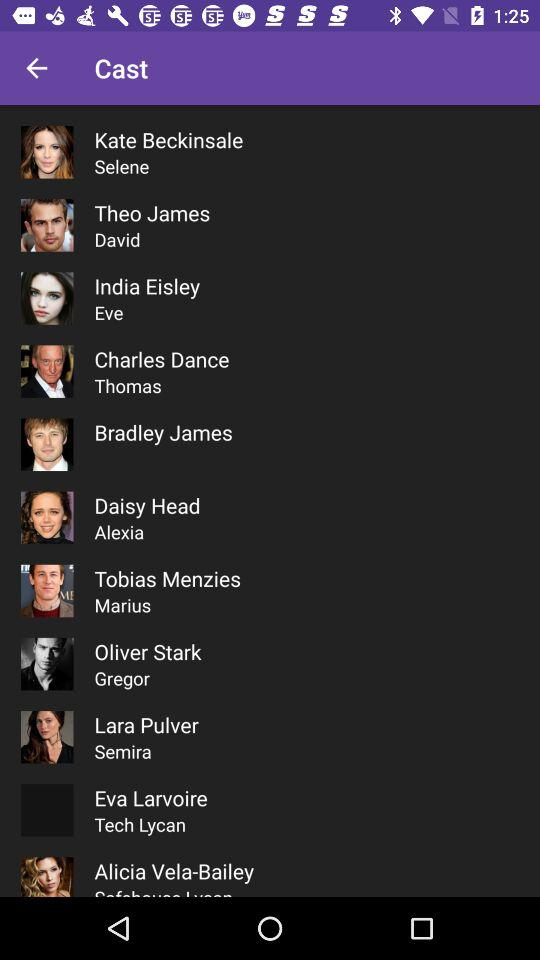What is the name of the artists available in the list? The names of the artists available in the list are Kate Beckinsale, Theo James, India Eisley, Charles Dance, Bradley James, Daisy Head, Tobias Menzies, Oliver Stark, Lara Pulver, Eva Larvoire, Alicia Vela-Bailey. 